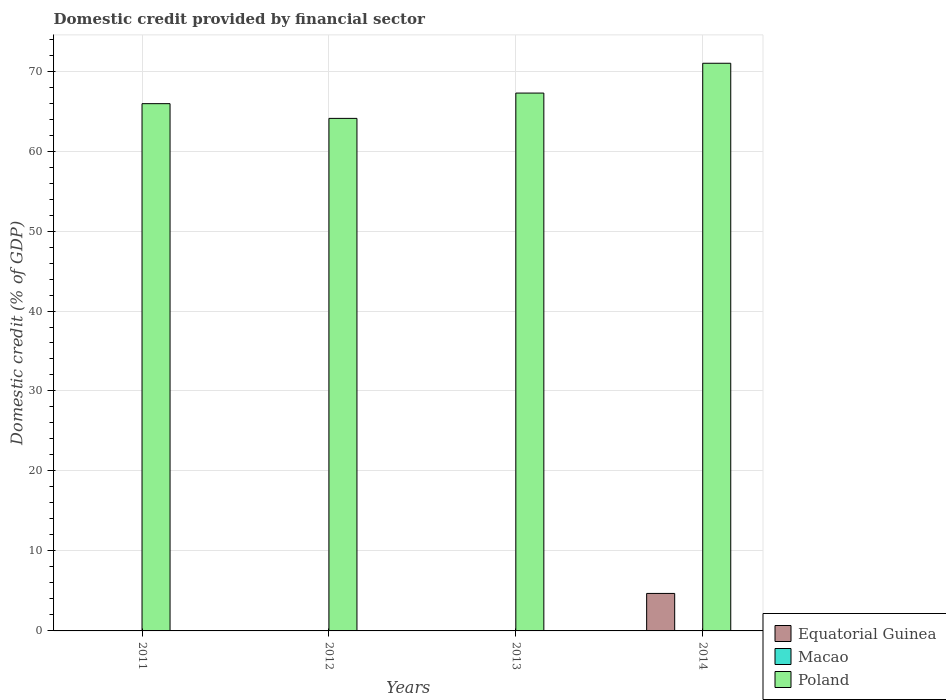How many different coloured bars are there?
Your answer should be very brief. 2. What is the label of the 1st group of bars from the left?
Offer a very short reply. 2011. In how many cases, is the number of bars for a given year not equal to the number of legend labels?
Your answer should be very brief. 4. Across all years, what is the maximum domestic credit in Poland?
Provide a succinct answer. 70.98. Across all years, what is the minimum domestic credit in Poland?
Your response must be concise. 64.08. What is the total domestic credit in Poland in the graph?
Give a very brief answer. 268.23. What is the difference between the domestic credit in Poland in 2011 and that in 2013?
Keep it short and to the point. -1.32. What is the difference between the domestic credit in Equatorial Guinea in 2014 and the domestic credit in Macao in 2012?
Provide a succinct answer. 4.69. What is the average domestic credit in Macao per year?
Provide a succinct answer. 0. In the year 2014, what is the difference between the domestic credit in Poland and domestic credit in Equatorial Guinea?
Provide a short and direct response. 66.29. In how many years, is the domestic credit in Equatorial Guinea greater than 22 %?
Your answer should be very brief. 0. What is the ratio of the domestic credit in Poland in 2011 to that in 2013?
Provide a short and direct response. 0.98. What is the difference between the highest and the second highest domestic credit in Poland?
Give a very brief answer. 3.73. What is the difference between the highest and the lowest domestic credit in Equatorial Guinea?
Provide a short and direct response. 4.69. In how many years, is the domestic credit in Macao greater than the average domestic credit in Macao taken over all years?
Your answer should be very brief. 0. Is it the case that in every year, the sum of the domestic credit in Macao and domestic credit in Poland is greater than the domestic credit in Equatorial Guinea?
Give a very brief answer. Yes. How many bars are there?
Offer a very short reply. 5. What is the difference between two consecutive major ticks on the Y-axis?
Your answer should be very brief. 10. Are the values on the major ticks of Y-axis written in scientific E-notation?
Your answer should be very brief. No. What is the title of the graph?
Offer a terse response. Domestic credit provided by financial sector. What is the label or title of the Y-axis?
Provide a succinct answer. Domestic credit (% of GDP). What is the Domestic credit (% of GDP) of Macao in 2011?
Your response must be concise. 0. What is the Domestic credit (% of GDP) of Poland in 2011?
Your answer should be compact. 65.92. What is the Domestic credit (% of GDP) of Equatorial Guinea in 2012?
Offer a terse response. 0. What is the Domestic credit (% of GDP) in Poland in 2012?
Keep it short and to the point. 64.08. What is the Domestic credit (% of GDP) of Equatorial Guinea in 2013?
Offer a terse response. 0. What is the Domestic credit (% of GDP) of Poland in 2013?
Your response must be concise. 67.25. What is the Domestic credit (% of GDP) in Equatorial Guinea in 2014?
Offer a very short reply. 4.69. What is the Domestic credit (% of GDP) in Poland in 2014?
Ensure brevity in your answer.  70.98. Across all years, what is the maximum Domestic credit (% of GDP) of Equatorial Guinea?
Keep it short and to the point. 4.69. Across all years, what is the maximum Domestic credit (% of GDP) of Poland?
Provide a succinct answer. 70.98. Across all years, what is the minimum Domestic credit (% of GDP) in Poland?
Offer a terse response. 64.08. What is the total Domestic credit (% of GDP) of Equatorial Guinea in the graph?
Provide a succinct answer. 4.69. What is the total Domestic credit (% of GDP) of Poland in the graph?
Offer a terse response. 268.23. What is the difference between the Domestic credit (% of GDP) of Poland in 2011 and that in 2012?
Offer a very short reply. 1.84. What is the difference between the Domestic credit (% of GDP) of Poland in 2011 and that in 2013?
Keep it short and to the point. -1.32. What is the difference between the Domestic credit (% of GDP) in Poland in 2011 and that in 2014?
Your response must be concise. -5.05. What is the difference between the Domestic credit (% of GDP) of Poland in 2012 and that in 2013?
Provide a succinct answer. -3.16. What is the difference between the Domestic credit (% of GDP) of Poland in 2012 and that in 2014?
Offer a terse response. -6.89. What is the difference between the Domestic credit (% of GDP) in Poland in 2013 and that in 2014?
Offer a terse response. -3.73. What is the average Domestic credit (% of GDP) of Equatorial Guinea per year?
Ensure brevity in your answer.  1.17. What is the average Domestic credit (% of GDP) in Poland per year?
Your answer should be very brief. 67.06. In the year 2014, what is the difference between the Domestic credit (% of GDP) in Equatorial Guinea and Domestic credit (% of GDP) in Poland?
Your response must be concise. -66.29. What is the ratio of the Domestic credit (% of GDP) of Poland in 2011 to that in 2012?
Provide a short and direct response. 1.03. What is the ratio of the Domestic credit (% of GDP) of Poland in 2011 to that in 2013?
Provide a succinct answer. 0.98. What is the ratio of the Domestic credit (% of GDP) in Poland in 2011 to that in 2014?
Your answer should be compact. 0.93. What is the ratio of the Domestic credit (% of GDP) of Poland in 2012 to that in 2013?
Make the answer very short. 0.95. What is the ratio of the Domestic credit (% of GDP) in Poland in 2012 to that in 2014?
Ensure brevity in your answer.  0.9. What is the ratio of the Domestic credit (% of GDP) of Poland in 2013 to that in 2014?
Offer a terse response. 0.95. What is the difference between the highest and the second highest Domestic credit (% of GDP) of Poland?
Make the answer very short. 3.73. What is the difference between the highest and the lowest Domestic credit (% of GDP) in Equatorial Guinea?
Ensure brevity in your answer.  4.69. What is the difference between the highest and the lowest Domestic credit (% of GDP) of Poland?
Your answer should be compact. 6.89. 